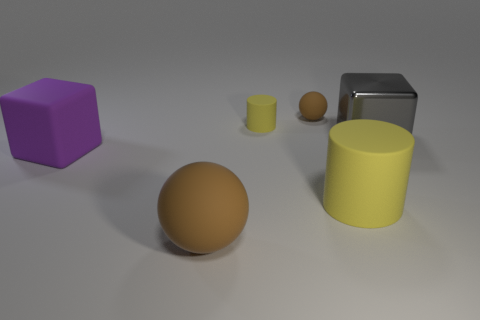The yellow object that is the same size as the rubber cube is what shape?
Ensure brevity in your answer.  Cylinder. What size is the brown rubber thing that is in front of the big yellow object?
Keep it short and to the point. Large. Does the matte sphere that is in front of the small rubber ball have the same color as the sphere that is behind the big purple thing?
Your response must be concise. Yes. What material is the cube on the right side of the matte thing that is behind the yellow matte thing that is to the left of the big yellow rubber thing?
Keep it short and to the point. Metal. Is there a brown ball that has the same size as the purple matte cube?
Your answer should be compact. Yes. There is a gray cube that is the same size as the purple rubber cube; what is it made of?
Provide a succinct answer. Metal. There is a big matte thing right of the big brown object; what is its shape?
Your response must be concise. Cylinder. Does the block that is on the right side of the purple matte block have the same material as the brown thing behind the metal object?
Your answer should be compact. No. How many other large matte objects are the same shape as the big gray object?
Ensure brevity in your answer.  1. What number of things are either tiny purple shiny things or brown rubber balls in front of the tiny brown sphere?
Provide a short and direct response. 1. 